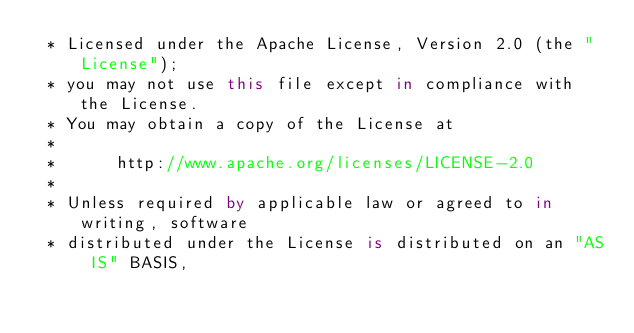Convert code to text. <code><loc_0><loc_0><loc_500><loc_500><_Kotlin_> * Licensed under the Apache License, Version 2.0 (the "License");
 * you may not use this file except in compliance with the License.
 * You may obtain a copy of the License at
 * 
 *      http://www.apache.org/licenses/LICENSE-2.0
 * 
 * Unless required by applicable law or agreed to in writing, software
 * distributed under the License is distributed on an "AS IS" BASIS,</code> 